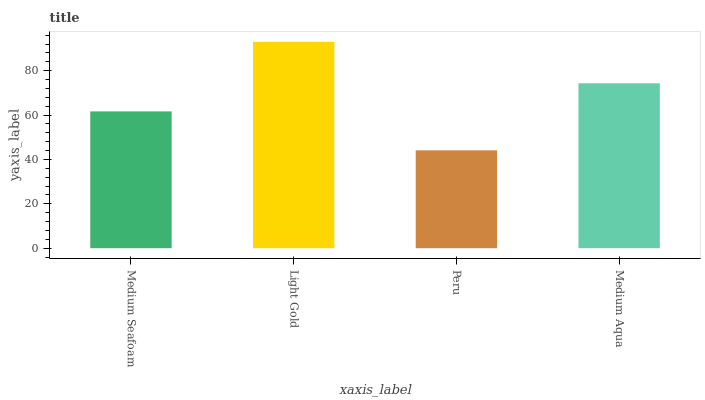Is Peru the minimum?
Answer yes or no. Yes. Is Light Gold the maximum?
Answer yes or no. Yes. Is Light Gold the minimum?
Answer yes or no. No. Is Peru the maximum?
Answer yes or no. No. Is Light Gold greater than Peru?
Answer yes or no. Yes. Is Peru less than Light Gold?
Answer yes or no. Yes. Is Peru greater than Light Gold?
Answer yes or no. No. Is Light Gold less than Peru?
Answer yes or no. No. Is Medium Aqua the high median?
Answer yes or no. Yes. Is Medium Seafoam the low median?
Answer yes or no. Yes. Is Medium Seafoam the high median?
Answer yes or no. No. Is Light Gold the low median?
Answer yes or no. No. 